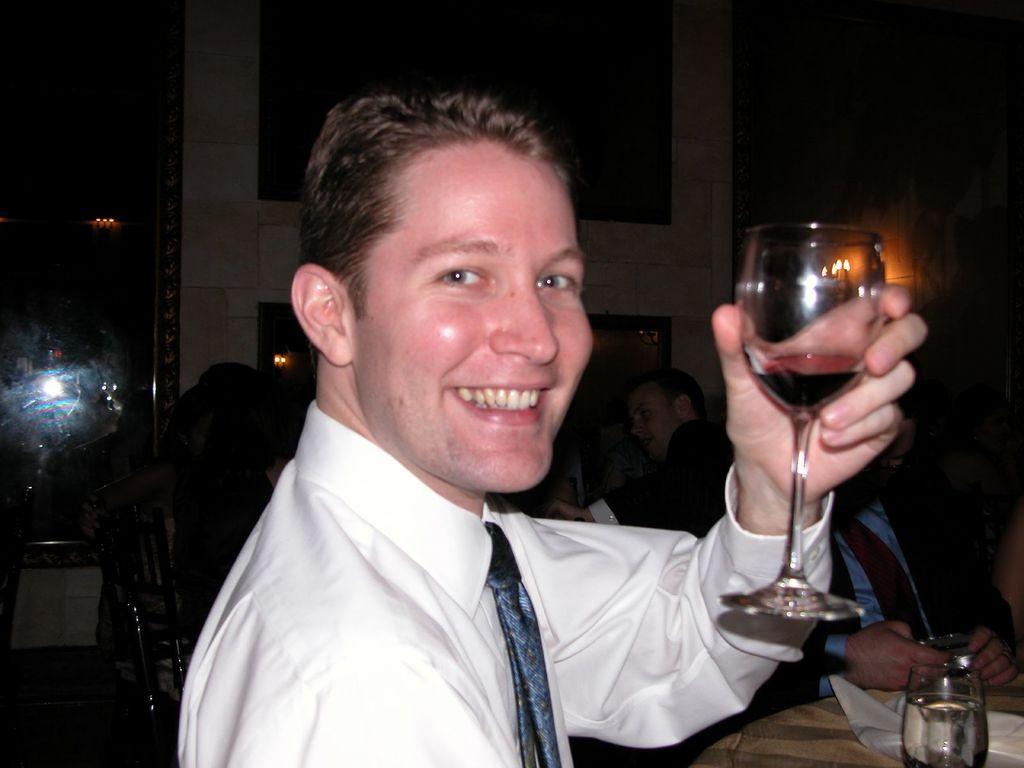Describe this image in one or two sentences. In this image I see a man who is smiling and holding a glass in his hand. In the background i see lot of people sitting on the chairs and a table over here and a glass on it. 